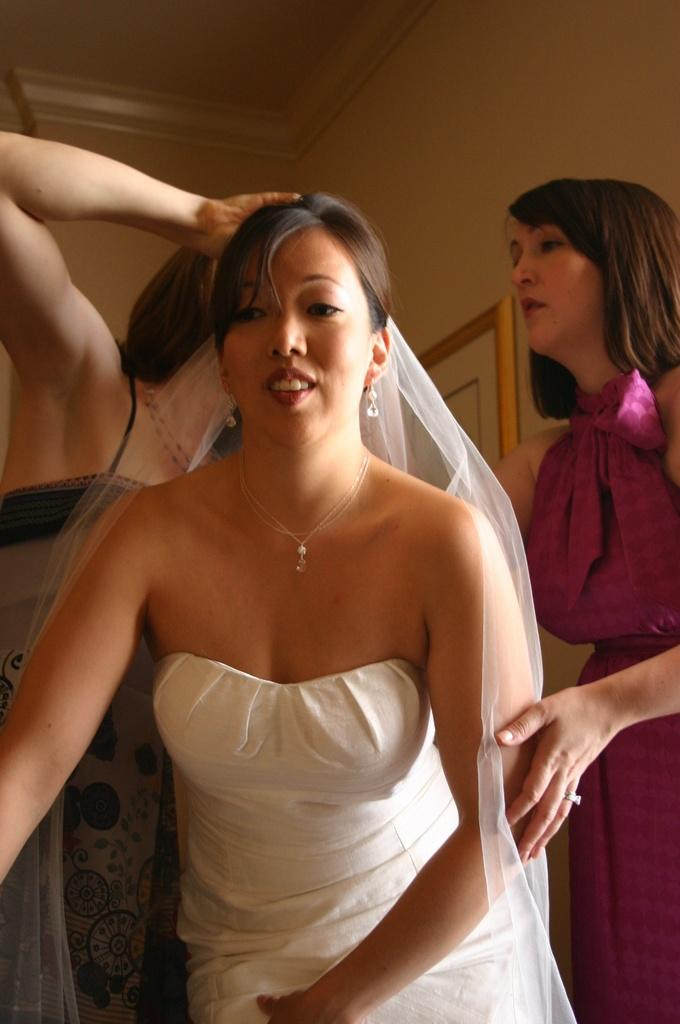How many people are in the image? There are three women in the image. Can you describe the attire of one of the women? One of the women is wearing a white gown. What type of toe jewelry is visible on the women in the image? There is no toe jewelry visible on the women in the image. 